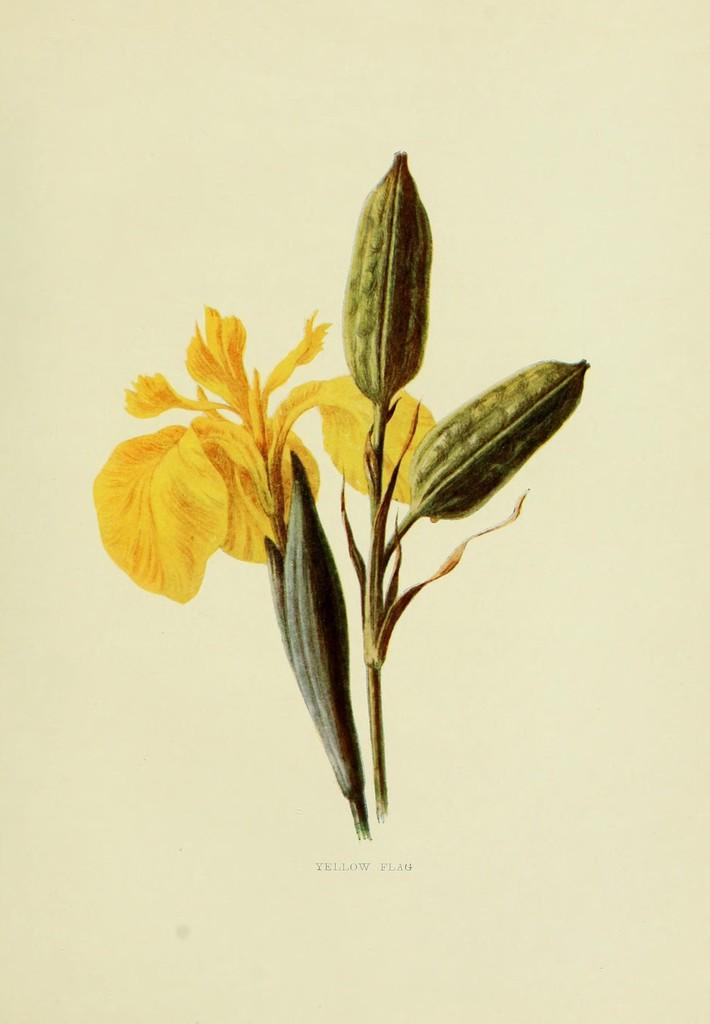What type of plants can be seen in the image? There are flowers in the image. Can you describe the stage of growth for some of the plants in the image? Yes, there are buds in the image, which are flowers in the early stages of development. What type of muscle can be seen in the image? There is no muscle present in the image; it features flowers and buds. How does the cat interact with the flowers in the image? There is no cat present in the image, so it cannot interact with the flowers. 